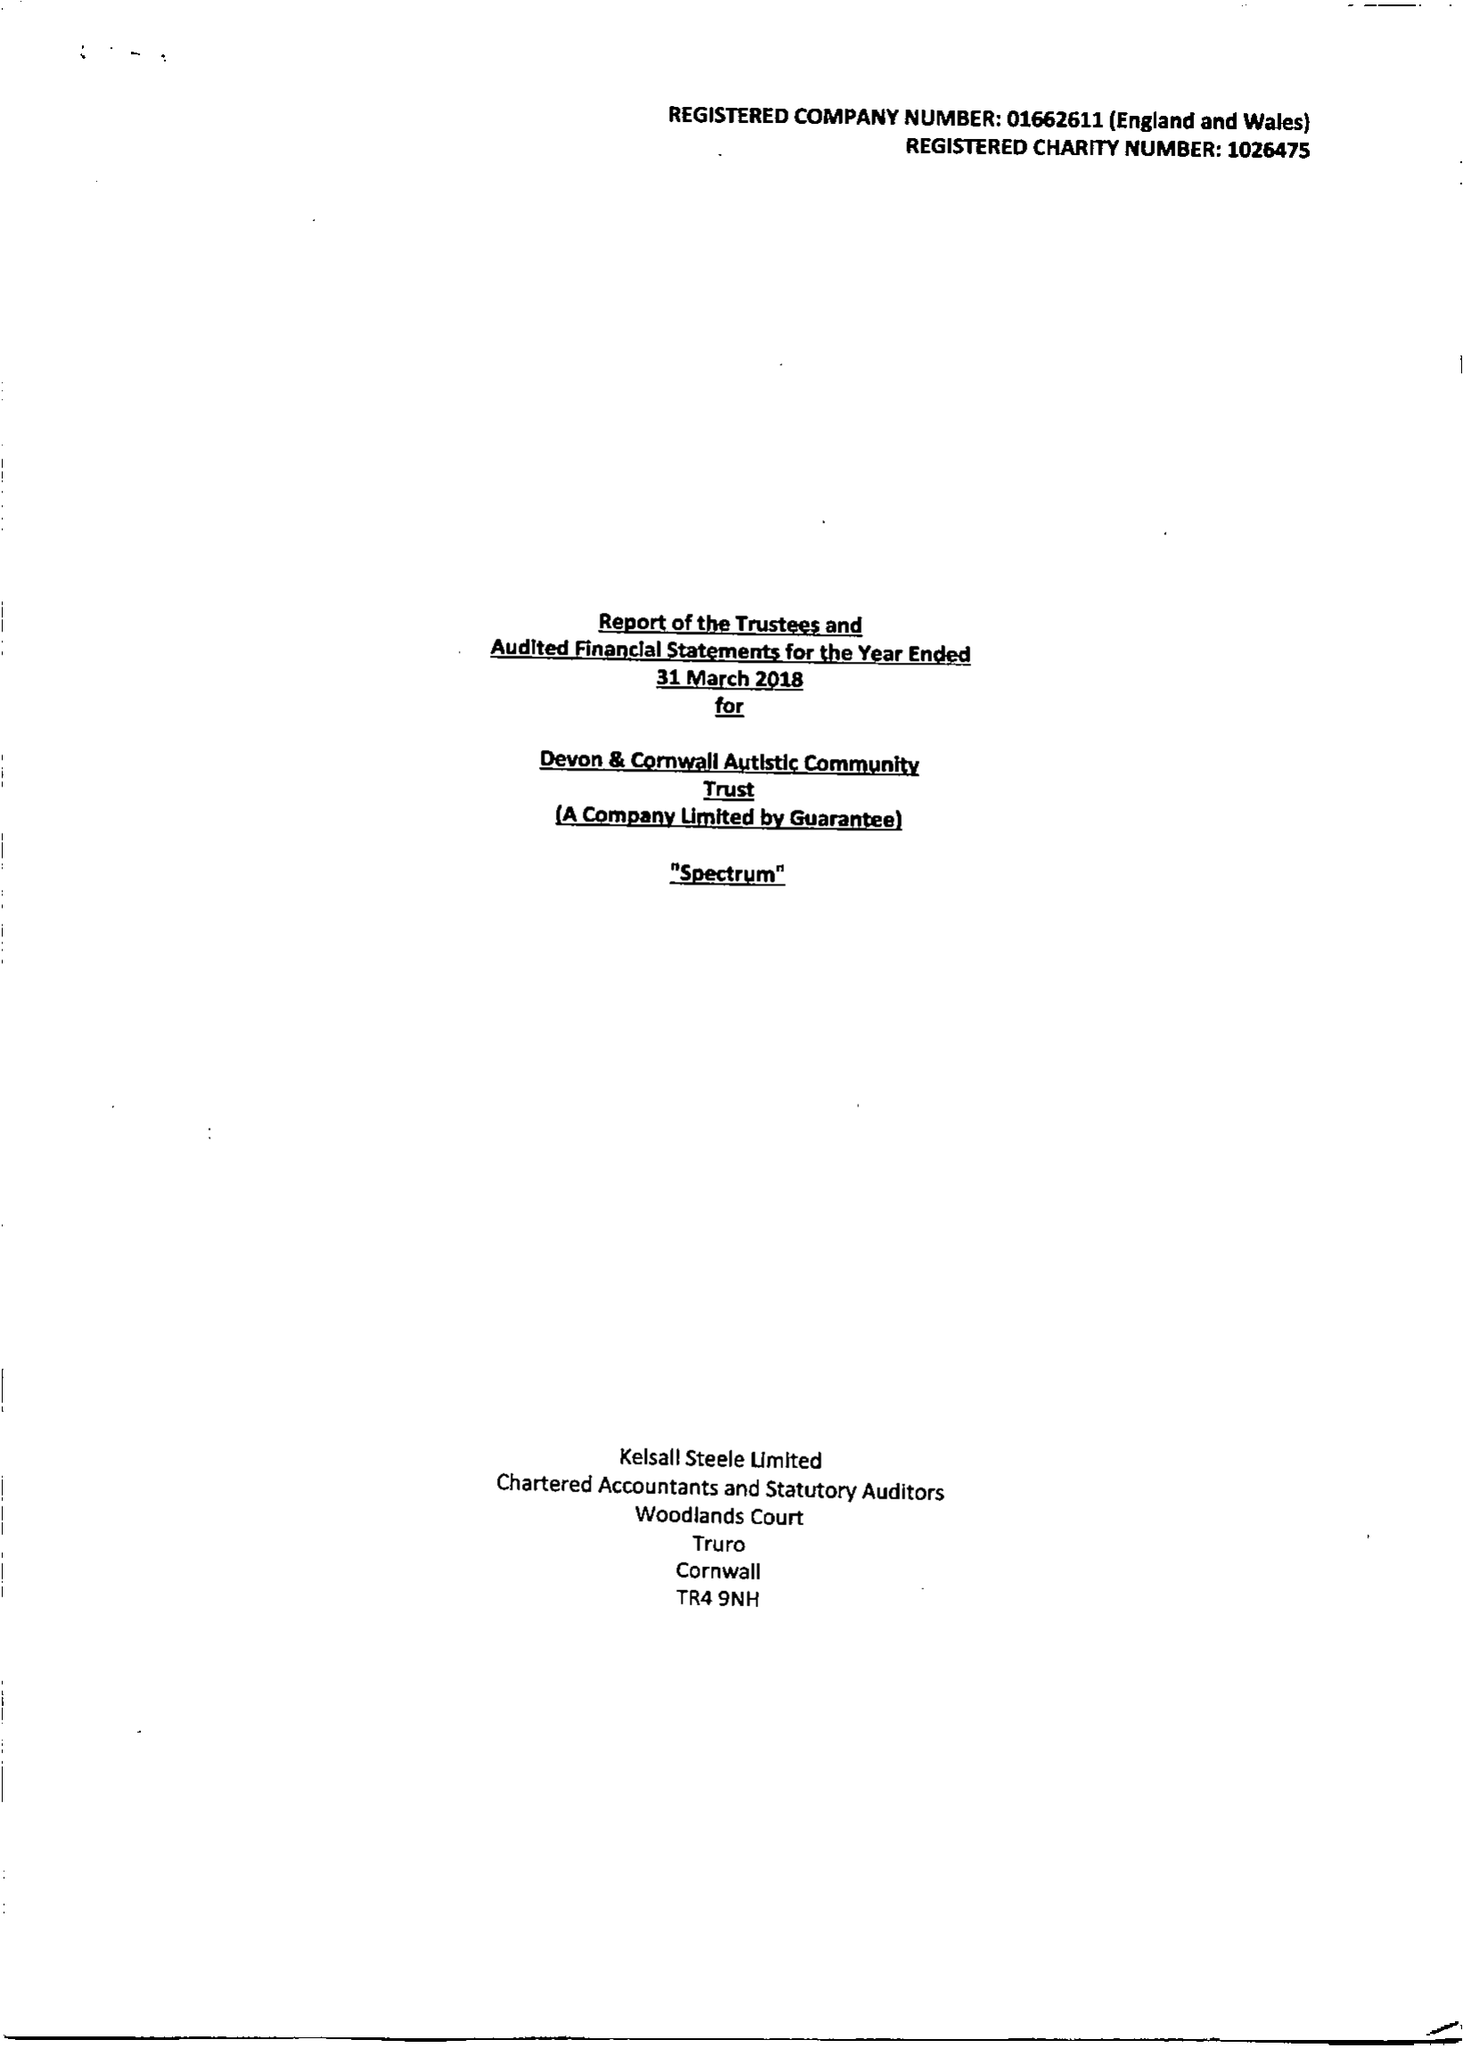What is the value for the charity_number?
Answer the question using a single word or phrase. 1026475 